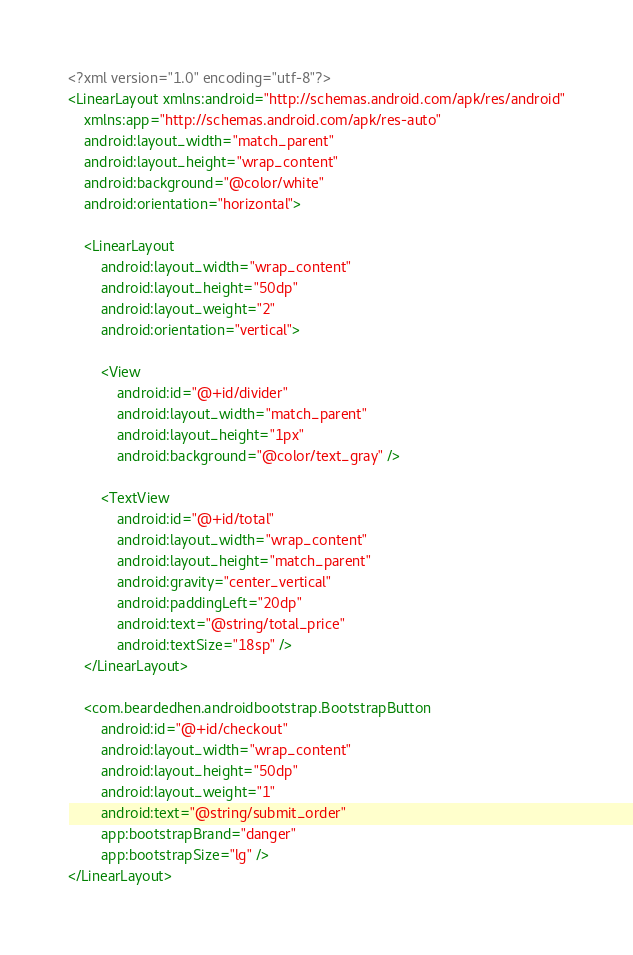Convert code to text. <code><loc_0><loc_0><loc_500><loc_500><_XML_><?xml version="1.0" encoding="utf-8"?>
<LinearLayout xmlns:android="http://schemas.android.com/apk/res/android"
    xmlns:app="http://schemas.android.com/apk/res-auto"
    android:layout_width="match_parent"
    android:layout_height="wrap_content"
    android:background="@color/white"
    android:orientation="horizontal">

    <LinearLayout
        android:layout_width="wrap_content"
        android:layout_height="50dp"
        android:layout_weight="2"
        android:orientation="vertical">

        <View
            android:id="@+id/divider"
            android:layout_width="match_parent"
            android:layout_height="1px"
            android:background="@color/text_gray" />

        <TextView
            android:id="@+id/total"
            android:layout_width="wrap_content"
            android:layout_height="match_parent"
            android:gravity="center_vertical"
            android:paddingLeft="20dp"
            android:text="@string/total_price"
            android:textSize="18sp" />
    </LinearLayout>

    <com.beardedhen.androidbootstrap.BootstrapButton
        android:id="@+id/checkout"
        android:layout_width="wrap_content"
        android:layout_height="50dp"
        android:layout_weight="1"
        android:text="@string/submit_order"
        app:bootstrapBrand="danger"
        app:bootstrapSize="lg" />
</LinearLayout></code> 